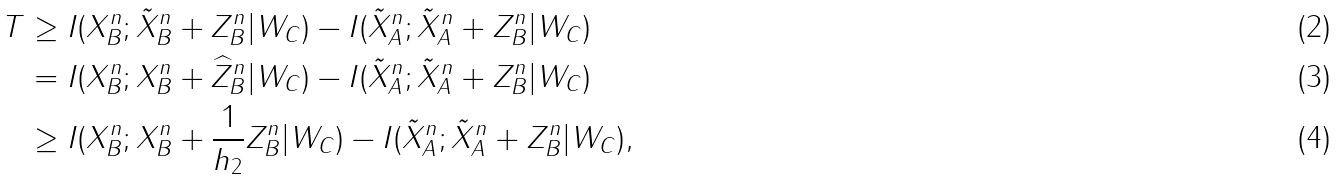Convert formula to latex. <formula><loc_0><loc_0><loc_500><loc_500>T & \geq I ( X _ { B } ^ { n } ; \tilde { X } _ { B } ^ { n } + Z _ { B } ^ { n } | W _ { C } ) - I ( \tilde { X } _ { A } ^ { n } ; \tilde { X } _ { A } ^ { n } + Z _ { B } ^ { n } | W _ { C } ) \\ & = I ( X _ { B } ^ { n } ; X _ { B } ^ { n } + \widehat { Z } _ { B } ^ { n } | W _ { C } ) - I ( \tilde { X } _ { A } ^ { n } ; \tilde { X } _ { A } ^ { n } + Z _ { B } ^ { n } | W _ { C } ) \\ & \geq I ( X _ { B } ^ { n } ; X _ { B } ^ { n } + \frac { 1 } { h _ { 2 } } Z _ { B } ^ { n } | W _ { C } ) - I ( \tilde { X } _ { A } ^ { n } ; \tilde { X } _ { A } ^ { n } + Z _ { B } ^ { n } | W _ { C } ) ,</formula> 